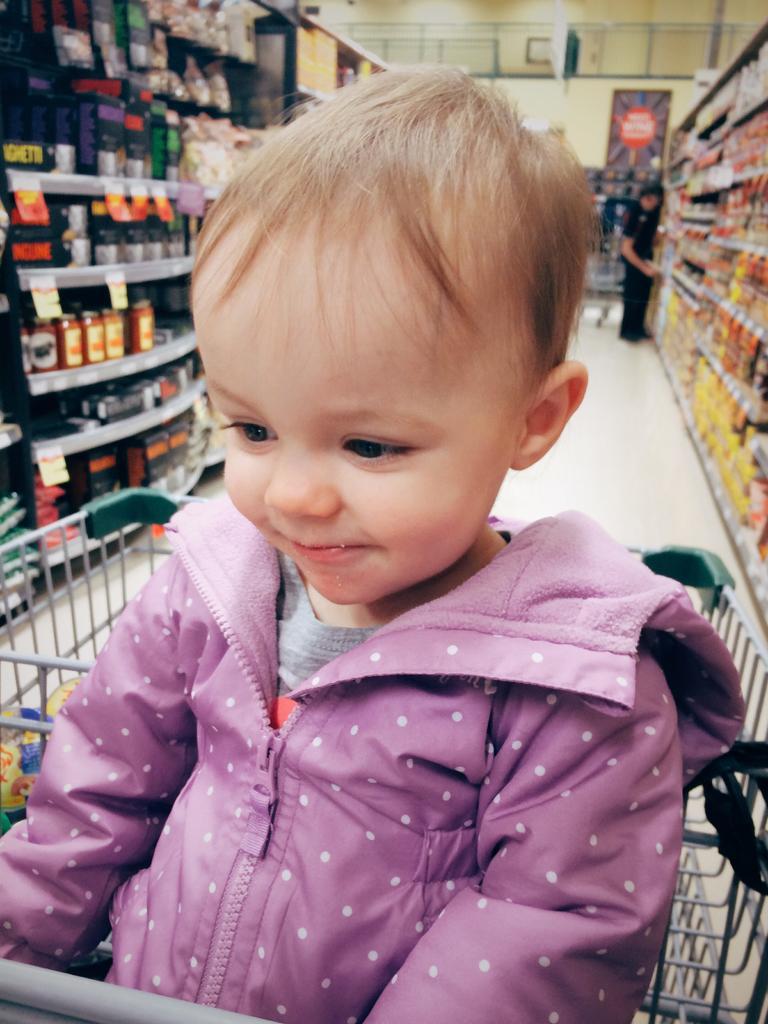Describe this image in one or two sentences. Front we can see a baby. Background there are cracks filled with objects. Far a person is standing beside this rack. 